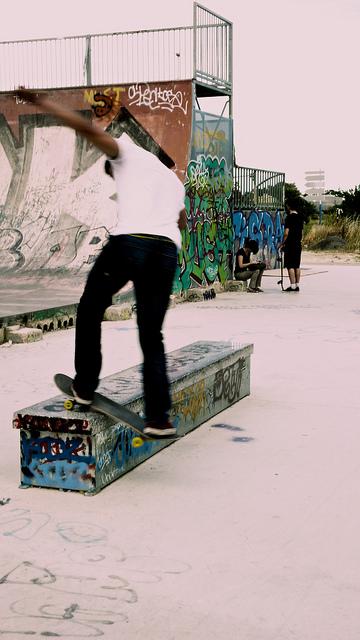What is the guy doing?
Quick response, please. Skateboarding. What type of art has been painted on the skate ramp?
Short answer required. Graffiti. What is the boy practicing?
Be succinct. Skateboarding. What is on the walls and bench?
Be succinct. Graffiti. 